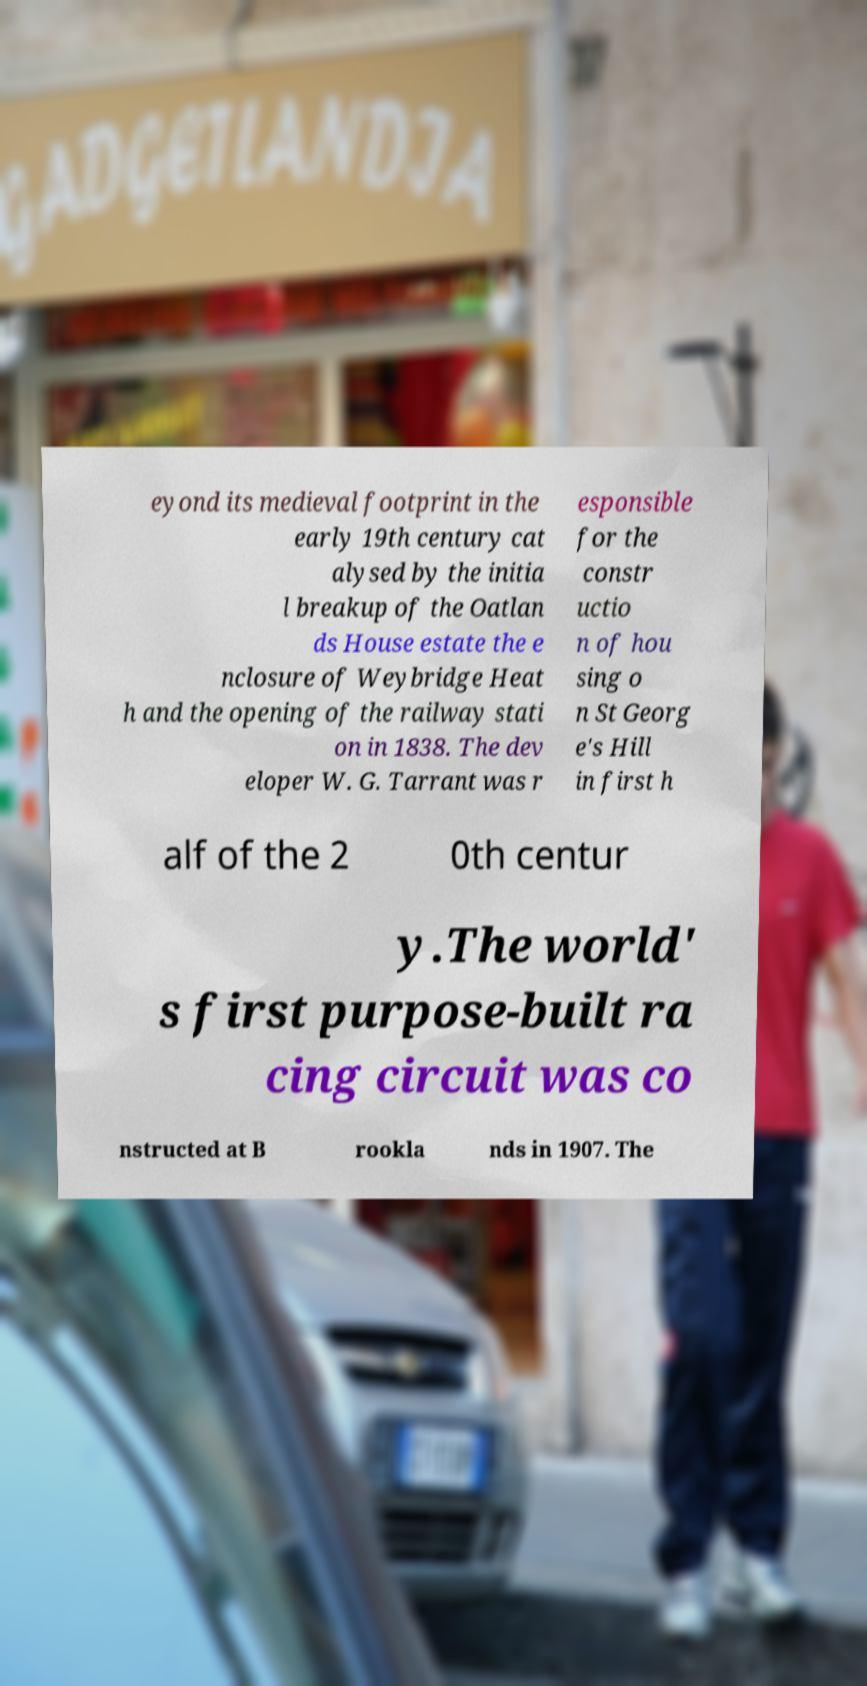Could you extract and type out the text from this image? eyond its medieval footprint in the early 19th century cat alysed by the initia l breakup of the Oatlan ds House estate the e nclosure of Weybridge Heat h and the opening of the railway stati on in 1838. The dev eloper W. G. Tarrant was r esponsible for the constr uctio n of hou sing o n St Georg e's Hill in first h alf of the 2 0th centur y.The world' s first purpose-built ra cing circuit was co nstructed at B rookla nds in 1907. The 